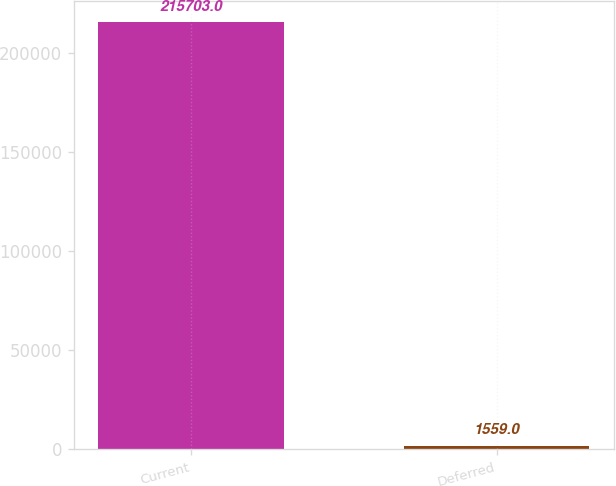Convert chart to OTSL. <chart><loc_0><loc_0><loc_500><loc_500><bar_chart><fcel>Current<fcel>Deferred<nl><fcel>215703<fcel>1559<nl></chart> 